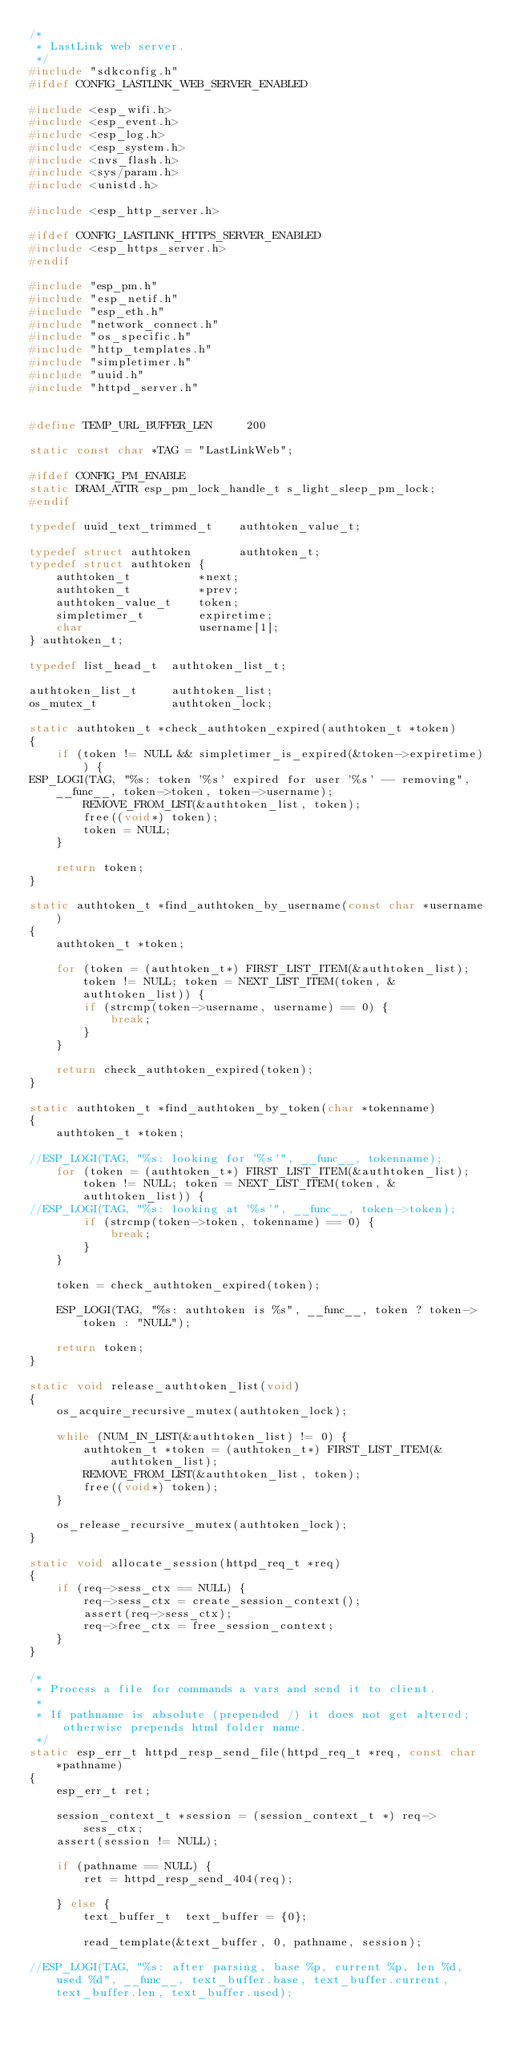Convert code to text. <code><loc_0><loc_0><loc_500><loc_500><_C_>/*
 * LastLink web server.
 */
#include "sdkconfig.h"
#ifdef CONFIG_LASTLINK_WEB_SERVER_ENABLED

#include <esp_wifi.h>
#include <esp_event.h>
#include <esp_log.h>
#include <esp_system.h>
#include <nvs_flash.h>
#include <sys/param.h>
#include <unistd.h>

#include <esp_http_server.h>

#ifdef CONFIG_LASTLINK_HTTPS_SERVER_ENABLED
#include <esp_https_server.h>
#endif

#include "esp_pm.h"
#include "esp_netif.h"
#include "esp_eth.h"
#include "network_connect.h"
#include "os_specific.h"
#include "http_templates.h"
#include "simpletimer.h"
#include "uuid.h"
#include "httpd_server.h"


#define TEMP_URL_BUFFER_LEN     200

static const char *TAG = "LastLinkWeb";

#ifdef CONFIG_PM_ENABLE
static DRAM_ATTR esp_pm_lock_handle_t s_light_sleep_pm_lock;
#endif

typedef uuid_text_trimmed_t    authtoken_value_t;

typedef struct authtoken       authtoken_t;
typedef struct authtoken {
    authtoken_t          *next;
    authtoken_t          *prev;
    authtoken_value_t    token;
    simpletimer_t        expiretime;
    char                 username[1];
} authtoken_t;

typedef list_head_t  authtoken_list_t;

authtoken_list_t     authtoken_list;
os_mutex_t           authtoken_lock;

static authtoken_t *check_authtoken_expired(authtoken_t *token)
{
    if (token != NULL && simpletimer_is_expired(&token->expiretime)) {
ESP_LOGI(TAG, "%s: token '%s' expired for user '%s' -- removing", __func__, token->token, token->username);
        REMOVE_FROM_LIST(&authtoken_list, token);
        free((void*) token);
        token = NULL;
    }

    return token;
}

static authtoken_t *find_authtoken_by_username(const char *username)
{
    authtoken_t *token;

    for (token = (authtoken_t*) FIRST_LIST_ITEM(&authtoken_list); token != NULL; token = NEXT_LIST_ITEM(token, &authtoken_list)) {
        if (strcmp(token->username, username) == 0) {
            break;
        }
    }

    return check_authtoken_expired(token);
}

static authtoken_t *find_authtoken_by_token(char *tokenname)
{
    authtoken_t *token;

//ESP_LOGI(TAG, "%s: looking for '%s'", __func__, tokenname);
    for (token = (authtoken_t*) FIRST_LIST_ITEM(&authtoken_list); token != NULL; token = NEXT_LIST_ITEM(token, &authtoken_list)) {
//ESP_LOGI(TAG, "%s: looking at '%s'", __func__, token->token);
        if (strcmp(token->token, tokenname) == 0) {
            break;
        }
    }

    token = check_authtoken_expired(token);

    ESP_LOGI(TAG, "%s: authtoken is %s", __func__, token ? token->token : "NULL");

    return token;
}

static void release_authtoken_list(void)
{
    os_acquire_recursive_mutex(authtoken_lock);

    while (NUM_IN_LIST(&authtoken_list) != 0) {
        authtoken_t *token = (authtoken_t*) FIRST_LIST_ITEM(&authtoken_list);
        REMOVE_FROM_LIST(&authtoken_list, token);
        free((void*) token);
    }

    os_release_recursive_mutex(authtoken_lock);
}

static void allocate_session(httpd_req_t *req)
{
    if (req->sess_ctx == NULL) {
        req->sess_ctx = create_session_context();
        assert(req->sess_ctx);
        req->free_ctx = free_session_context;
    }
}

/*
 * Process a file for commands a vars and send it to client.
 *
 * If pathname is absolute (prepended /) it does not get altered; otherwise prepends html folder name.
 */
static esp_err_t httpd_resp_send_file(httpd_req_t *req, const char *pathname)
{
    esp_err_t ret;

    session_context_t *session = (session_context_t *) req->sess_ctx;
    assert(session != NULL);

    if (pathname == NULL) {
        ret = httpd_resp_send_404(req);

    } else {
        text_buffer_t  text_buffer = {0};

        read_template(&text_buffer, 0, pathname, session);

//ESP_LOGI(TAG, "%s: after parsing, base %p, current %p, len %d, used %d", __func__, text_buffer.base, text_buffer.current, text_buffer.len, text_buffer.used);
</code> 